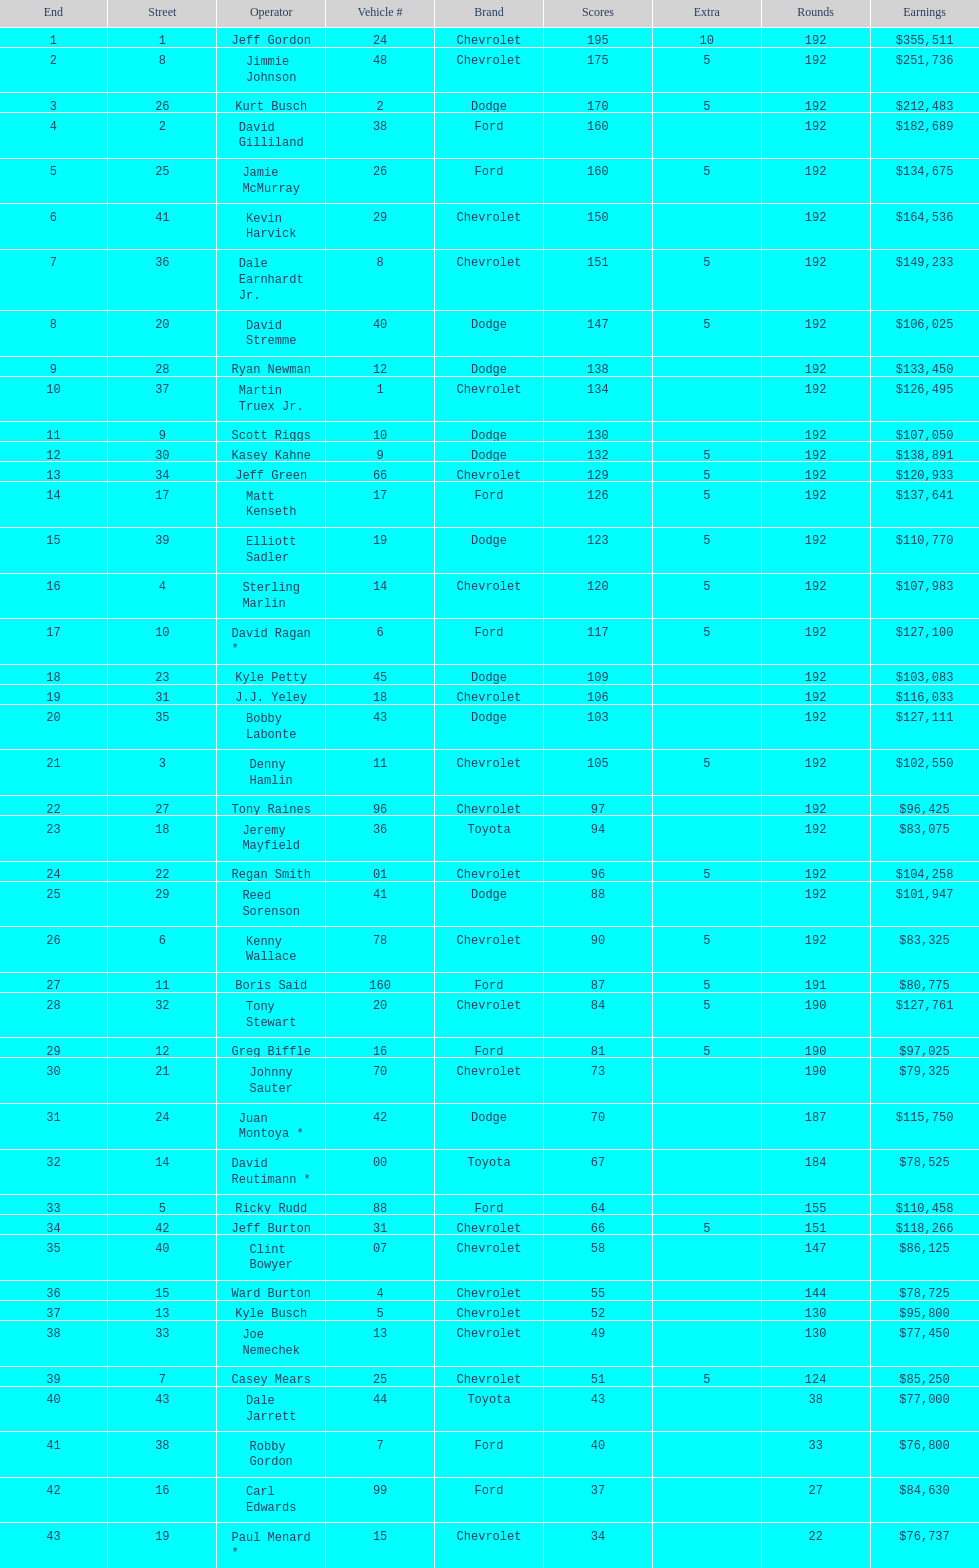How many drivers earned no bonus for this race? 23. 